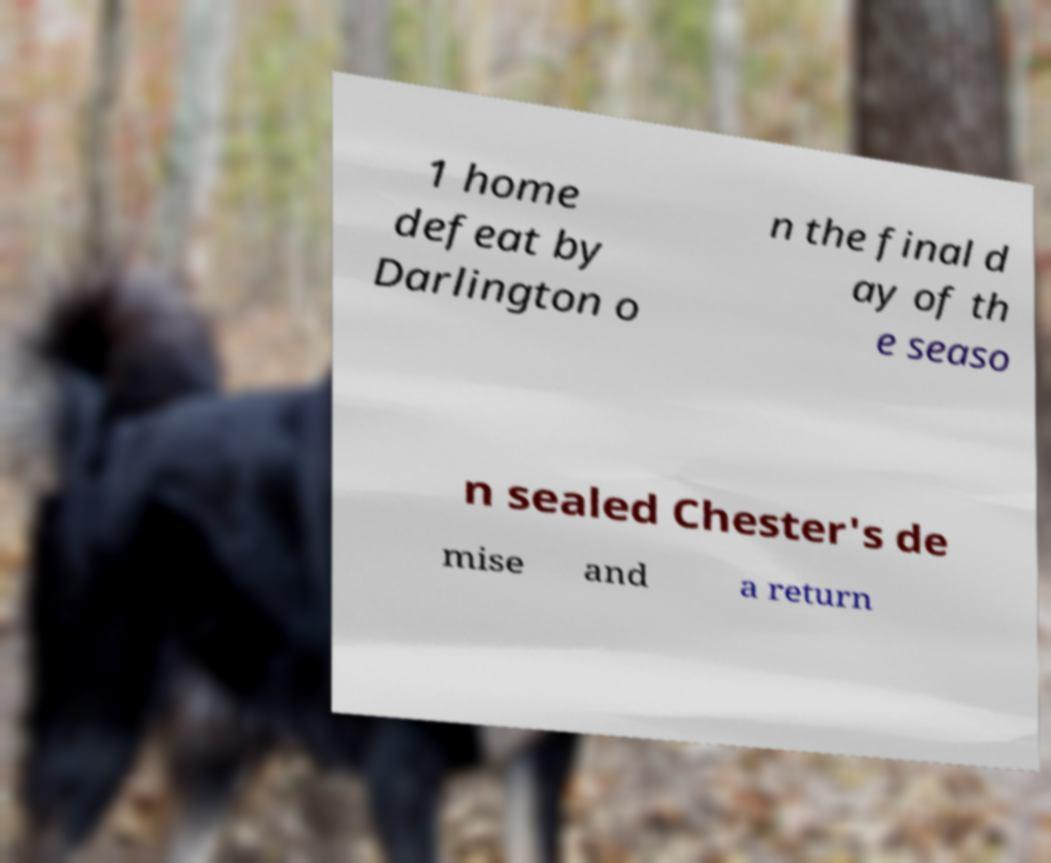Please identify and transcribe the text found in this image. 1 home defeat by Darlington o n the final d ay of th e seaso n sealed Chester's de mise and a return 